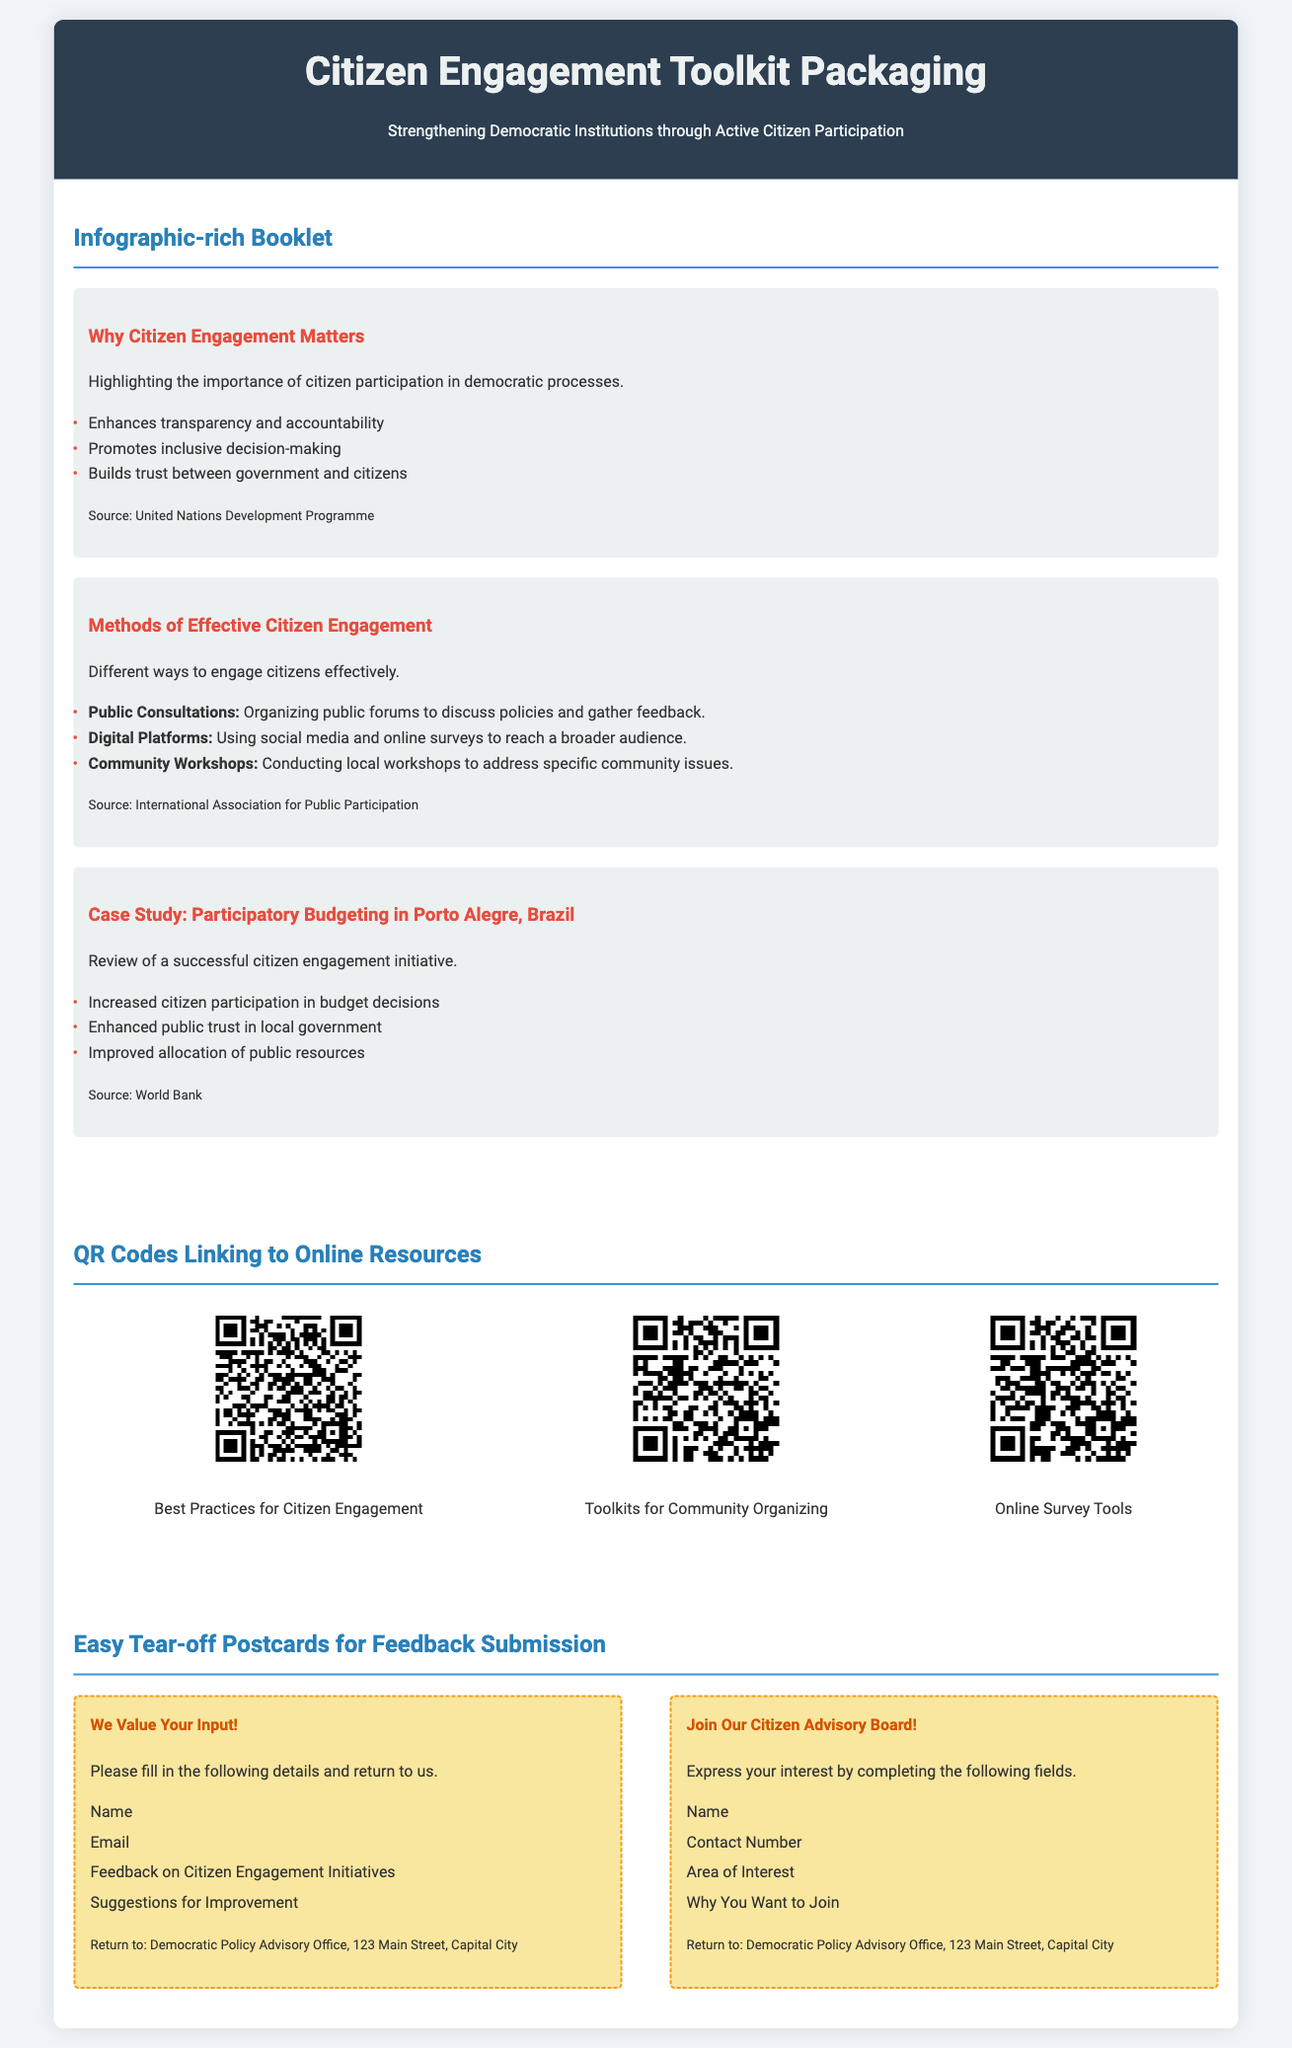What is the title of the toolkit? The title is prominently displayed in the header section of the document.
Answer: Citizen Engagement Toolkit Packaging What are the three methods of effective citizen engagement mentioned? The document lists methods in the infographic section that describe various citizen engagement strategies.
Answer: Public Consultations, Digital Platforms, Community Workshops How many QR codes are provided in the document? The QR codes section contains visual representations of links to resources, which can be counted.
Answer: Three What type of feedback postcards are included? The document details the content and purpose of the postcards specifically designed for engagement.
Answer: Easy Tear-off Postcards Which case study is highlighted in the document? The case study title is found in one of the infographic sections that showcase effective citizen initiatives.
Answer: Participatory Budgeting in Porto Alegre, Brazil What color theme is used in the header of the document? The document's header is described with specific colors that create a visual identity.
Answer: Dark blue and light grey How many items are listed under "Why Citizen Engagement Matters"? The number of items is contained in the infographic listing reasons for citizen participation.
Answer: Three What is the first step for individuals who want to join the Citizen Advisory Board? The postcard section outlines specific actions for expressing interest in participation, starting with certain information.
Answer: Completing the fields provided 